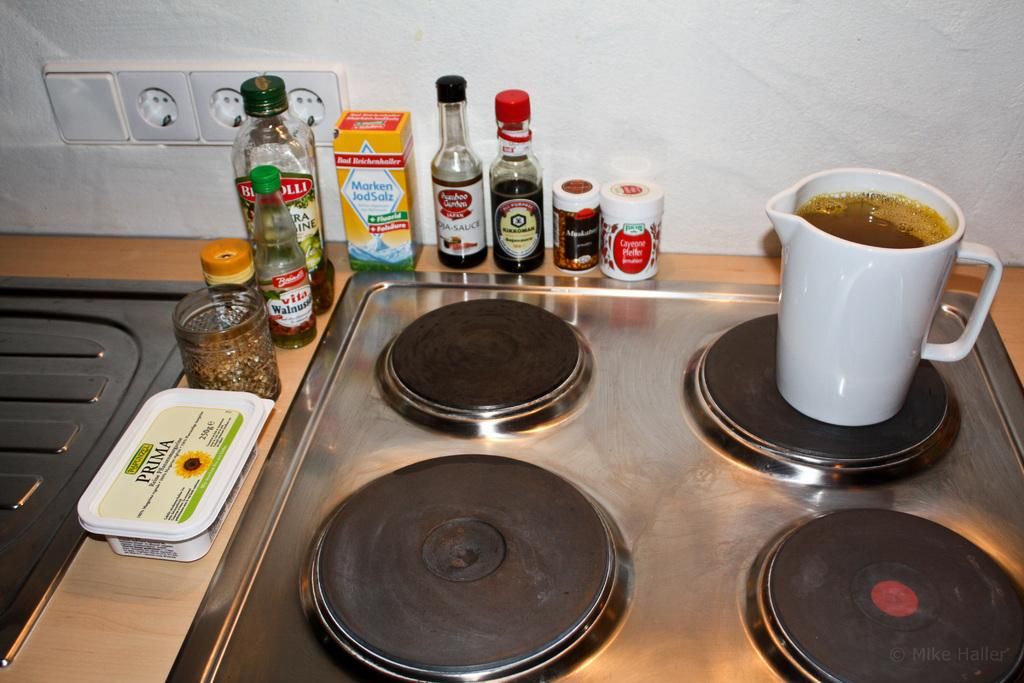What type of objects can be seen in the image? There are bottles, a mug, and a container in the image. What color are some of the objects in the image? There are black colored objects in the image. What is visible in the background of the image? There is a wall in the background of the image. Is there anything attached to the wall in the background? Yes, there is an object attached to the wall in the background. What type of mint is growing on the wall in the image? There is no mint growing on the wall in the image. What tax rate is applicable to the objects in the image? The image does not provide any information about tax rates, as it is not related to the content of the image. 